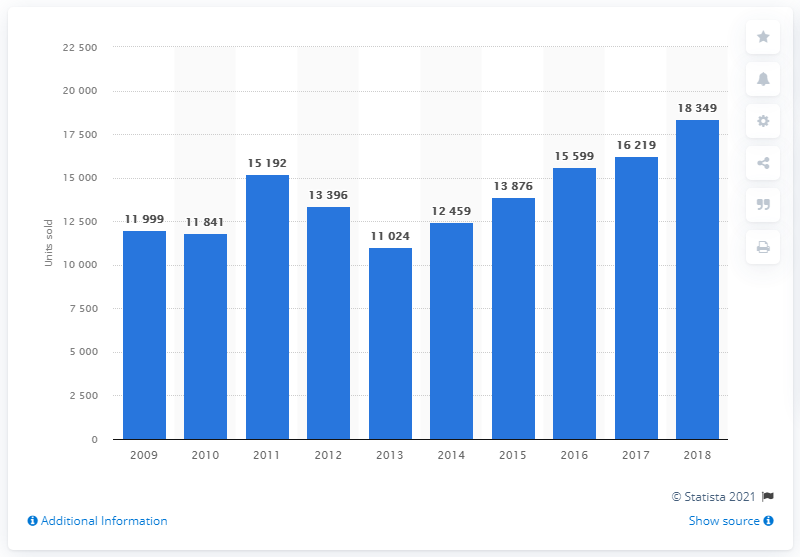Identify some key points in this picture. In 2015, the sales of Volvo cars in France totaled 13,876 units. 